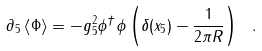Convert formula to latex. <formula><loc_0><loc_0><loc_500><loc_500>\partial _ { 5 } \left \langle { \Phi } \right \rangle = - g _ { 5 } ^ { 2 } \phi ^ { \dagger } \phi \left ( \delta ( x _ { 5 } ) - { \frac { 1 } { 2 \pi R } } \right ) \ .</formula> 